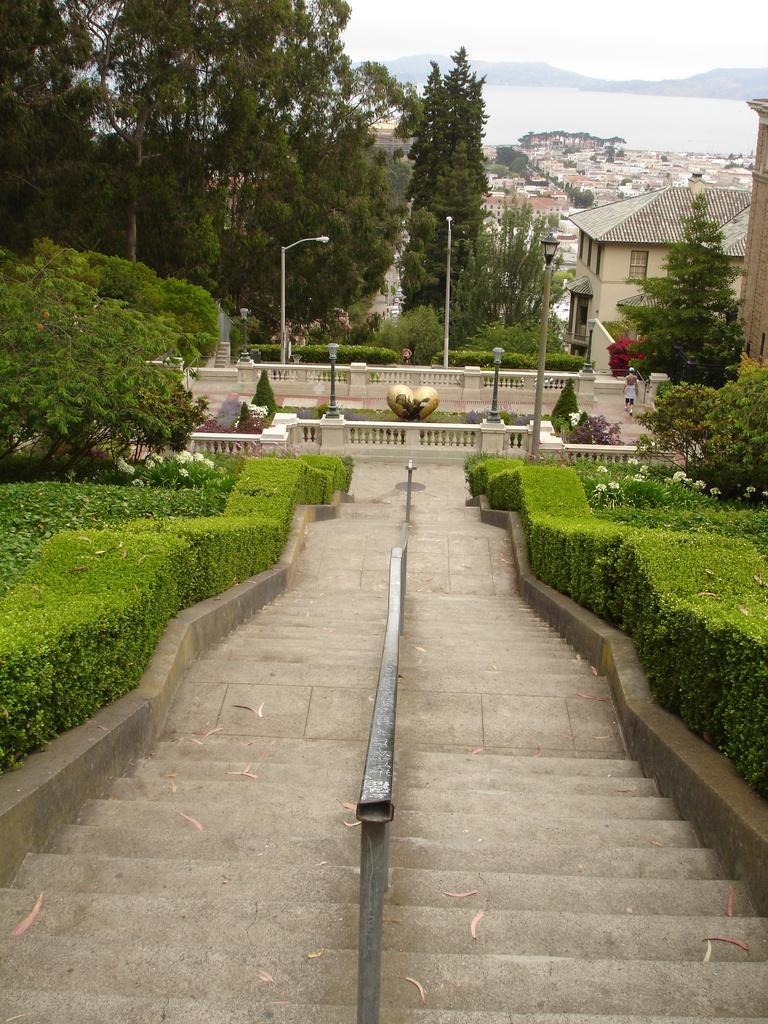Can you describe this image briefly? This is the picture of a city. In this image there are buildings and trees and poles. In the foreground there is a staircase and there is a hand rail and there are plants and flowers. At the back there is a mountain. At the top there is sky. At the bottom there is water. On the right side of the image there is a person walking. 